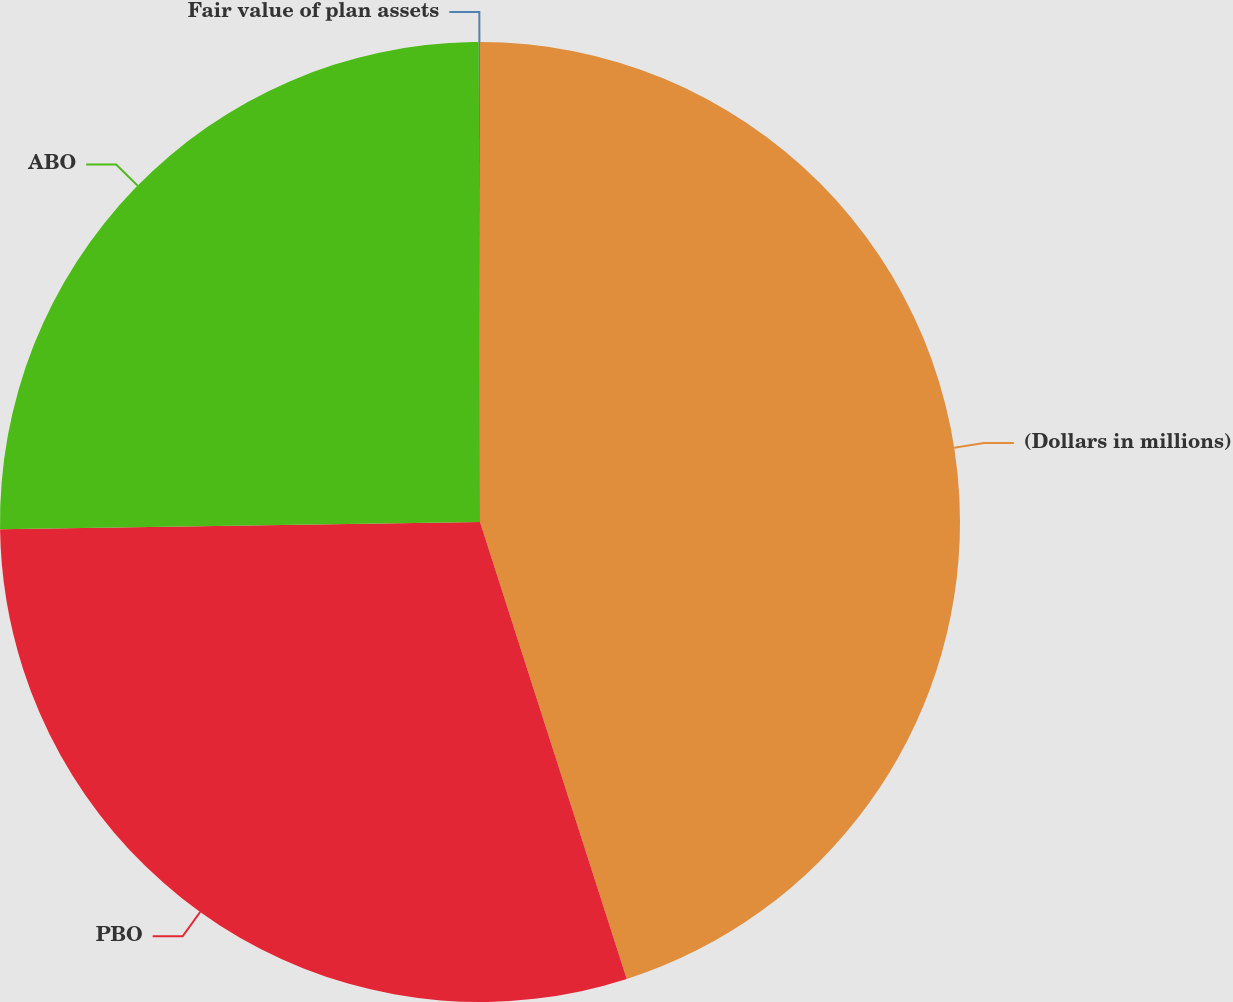<chart> <loc_0><loc_0><loc_500><loc_500><pie_chart><fcel>(Dollars in millions)<fcel>PBO<fcel>ABO<fcel>Fair value of plan assets<nl><fcel>45.05%<fcel>29.7%<fcel>25.2%<fcel>0.04%<nl></chart> 